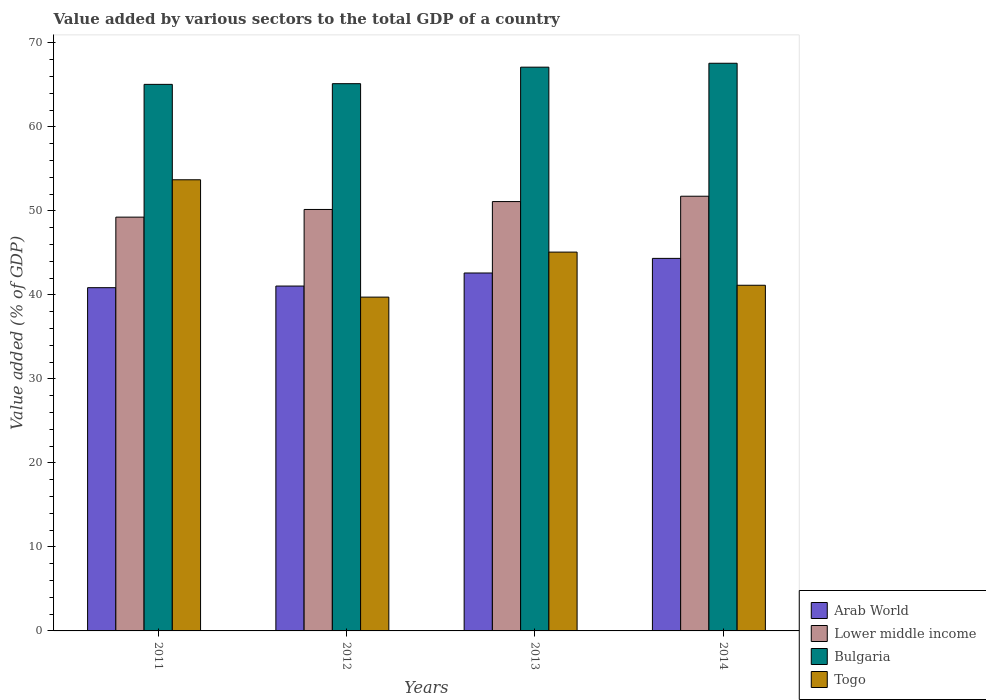How many different coloured bars are there?
Keep it short and to the point. 4. Are the number of bars on each tick of the X-axis equal?
Offer a very short reply. Yes. What is the value added by various sectors to the total GDP in Arab World in 2012?
Your answer should be compact. 41.05. Across all years, what is the maximum value added by various sectors to the total GDP in Togo?
Provide a succinct answer. 53.7. Across all years, what is the minimum value added by various sectors to the total GDP in Bulgaria?
Your response must be concise. 65.06. In which year was the value added by various sectors to the total GDP in Arab World minimum?
Your answer should be compact. 2011. What is the total value added by various sectors to the total GDP in Bulgaria in the graph?
Offer a very short reply. 264.86. What is the difference between the value added by various sectors to the total GDP in Togo in 2011 and that in 2014?
Offer a terse response. 12.56. What is the difference between the value added by various sectors to the total GDP in Arab World in 2011 and the value added by various sectors to the total GDP in Lower middle income in 2013?
Your answer should be compact. -10.25. What is the average value added by various sectors to the total GDP in Arab World per year?
Your answer should be very brief. 42.21. In the year 2011, what is the difference between the value added by various sectors to the total GDP in Lower middle income and value added by various sectors to the total GDP in Bulgaria?
Your answer should be compact. -15.8. What is the ratio of the value added by various sectors to the total GDP in Lower middle income in 2011 to that in 2013?
Offer a terse response. 0.96. Is the value added by various sectors to the total GDP in Bulgaria in 2011 less than that in 2013?
Keep it short and to the point. Yes. What is the difference between the highest and the second highest value added by various sectors to the total GDP in Bulgaria?
Offer a terse response. 0.46. What is the difference between the highest and the lowest value added by various sectors to the total GDP in Bulgaria?
Make the answer very short. 2.51. Is the sum of the value added by various sectors to the total GDP in Lower middle income in 2013 and 2014 greater than the maximum value added by various sectors to the total GDP in Arab World across all years?
Provide a short and direct response. Yes. What does the 4th bar from the left in 2011 represents?
Your answer should be very brief. Togo. What does the 1st bar from the right in 2014 represents?
Provide a short and direct response. Togo. Is it the case that in every year, the sum of the value added by various sectors to the total GDP in Arab World and value added by various sectors to the total GDP in Lower middle income is greater than the value added by various sectors to the total GDP in Bulgaria?
Give a very brief answer. Yes. How many bars are there?
Your answer should be very brief. 16. Are all the bars in the graph horizontal?
Your answer should be compact. No. Does the graph contain grids?
Ensure brevity in your answer.  No. Where does the legend appear in the graph?
Your response must be concise. Bottom right. How are the legend labels stacked?
Offer a terse response. Vertical. What is the title of the graph?
Give a very brief answer. Value added by various sectors to the total GDP of a country. What is the label or title of the X-axis?
Your answer should be compact. Years. What is the label or title of the Y-axis?
Your response must be concise. Value added (% of GDP). What is the Value added (% of GDP) in Arab World in 2011?
Make the answer very short. 40.86. What is the Value added (% of GDP) of Lower middle income in 2011?
Your answer should be compact. 49.25. What is the Value added (% of GDP) of Bulgaria in 2011?
Your answer should be compact. 65.06. What is the Value added (% of GDP) in Togo in 2011?
Provide a short and direct response. 53.7. What is the Value added (% of GDP) of Arab World in 2012?
Give a very brief answer. 41.05. What is the Value added (% of GDP) in Lower middle income in 2012?
Offer a very short reply. 50.16. What is the Value added (% of GDP) in Bulgaria in 2012?
Keep it short and to the point. 65.14. What is the Value added (% of GDP) of Togo in 2012?
Offer a terse response. 39.73. What is the Value added (% of GDP) of Arab World in 2013?
Give a very brief answer. 42.6. What is the Value added (% of GDP) in Lower middle income in 2013?
Make the answer very short. 51.1. What is the Value added (% of GDP) of Bulgaria in 2013?
Your response must be concise. 67.1. What is the Value added (% of GDP) in Togo in 2013?
Keep it short and to the point. 45.09. What is the Value added (% of GDP) of Arab World in 2014?
Your response must be concise. 44.34. What is the Value added (% of GDP) of Lower middle income in 2014?
Your answer should be very brief. 51.74. What is the Value added (% of GDP) in Bulgaria in 2014?
Offer a terse response. 67.57. What is the Value added (% of GDP) of Togo in 2014?
Offer a terse response. 41.14. Across all years, what is the maximum Value added (% of GDP) of Arab World?
Keep it short and to the point. 44.34. Across all years, what is the maximum Value added (% of GDP) in Lower middle income?
Offer a very short reply. 51.74. Across all years, what is the maximum Value added (% of GDP) of Bulgaria?
Give a very brief answer. 67.57. Across all years, what is the maximum Value added (% of GDP) of Togo?
Make the answer very short. 53.7. Across all years, what is the minimum Value added (% of GDP) in Arab World?
Make the answer very short. 40.86. Across all years, what is the minimum Value added (% of GDP) in Lower middle income?
Provide a succinct answer. 49.25. Across all years, what is the minimum Value added (% of GDP) of Bulgaria?
Make the answer very short. 65.06. Across all years, what is the minimum Value added (% of GDP) of Togo?
Make the answer very short. 39.73. What is the total Value added (% of GDP) of Arab World in the graph?
Offer a very short reply. 168.85. What is the total Value added (% of GDP) in Lower middle income in the graph?
Keep it short and to the point. 202.26. What is the total Value added (% of GDP) in Bulgaria in the graph?
Offer a terse response. 264.86. What is the total Value added (% of GDP) of Togo in the graph?
Provide a succinct answer. 179.66. What is the difference between the Value added (% of GDP) in Arab World in 2011 and that in 2012?
Your answer should be very brief. -0.19. What is the difference between the Value added (% of GDP) of Lower middle income in 2011 and that in 2012?
Keep it short and to the point. -0.91. What is the difference between the Value added (% of GDP) in Bulgaria in 2011 and that in 2012?
Make the answer very short. -0.08. What is the difference between the Value added (% of GDP) of Togo in 2011 and that in 2012?
Your response must be concise. 13.97. What is the difference between the Value added (% of GDP) in Arab World in 2011 and that in 2013?
Keep it short and to the point. -1.75. What is the difference between the Value added (% of GDP) in Lower middle income in 2011 and that in 2013?
Make the answer very short. -1.85. What is the difference between the Value added (% of GDP) of Bulgaria in 2011 and that in 2013?
Offer a terse response. -2.05. What is the difference between the Value added (% of GDP) of Togo in 2011 and that in 2013?
Your response must be concise. 8.61. What is the difference between the Value added (% of GDP) in Arab World in 2011 and that in 2014?
Make the answer very short. -3.49. What is the difference between the Value added (% of GDP) in Lower middle income in 2011 and that in 2014?
Make the answer very short. -2.49. What is the difference between the Value added (% of GDP) in Bulgaria in 2011 and that in 2014?
Offer a terse response. -2.51. What is the difference between the Value added (% of GDP) in Togo in 2011 and that in 2014?
Make the answer very short. 12.56. What is the difference between the Value added (% of GDP) in Arab World in 2012 and that in 2013?
Your answer should be very brief. -1.55. What is the difference between the Value added (% of GDP) in Lower middle income in 2012 and that in 2013?
Your response must be concise. -0.94. What is the difference between the Value added (% of GDP) in Bulgaria in 2012 and that in 2013?
Provide a short and direct response. -1.97. What is the difference between the Value added (% of GDP) in Togo in 2012 and that in 2013?
Keep it short and to the point. -5.36. What is the difference between the Value added (% of GDP) in Arab World in 2012 and that in 2014?
Provide a succinct answer. -3.29. What is the difference between the Value added (% of GDP) of Lower middle income in 2012 and that in 2014?
Give a very brief answer. -1.58. What is the difference between the Value added (% of GDP) of Bulgaria in 2012 and that in 2014?
Your answer should be very brief. -2.43. What is the difference between the Value added (% of GDP) in Togo in 2012 and that in 2014?
Offer a very short reply. -1.41. What is the difference between the Value added (% of GDP) of Arab World in 2013 and that in 2014?
Offer a terse response. -1.74. What is the difference between the Value added (% of GDP) in Lower middle income in 2013 and that in 2014?
Offer a terse response. -0.64. What is the difference between the Value added (% of GDP) of Bulgaria in 2013 and that in 2014?
Offer a very short reply. -0.46. What is the difference between the Value added (% of GDP) of Togo in 2013 and that in 2014?
Your answer should be compact. 3.95. What is the difference between the Value added (% of GDP) in Arab World in 2011 and the Value added (% of GDP) in Lower middle income in 2012?
Your answer should be compact. -9.31. What is the difference between the Value added (% of GDP) of Arab World in 2011 and the Value added (% of GDP) of Bulgaria in 2012?
Give a very brief answer. -24.28. What is the difference between the Value added (% of GDP) of Arab World in 2011 and the Value added (% of GDP) of Togo in 2012?
Offer a very short reply. 1.12. What is the difference between the Value added (% of GDP) in Lower middle income in 2011 and the Value added (% of GDP) in Bulgaria in 2012?
Your answer should be very brief. -15.88. What is the difference between the Value added (% of GDP) of Lower middle income in 2011 and the Value added (% of GDP) of Togo in 2012?
Provide a short and direct response. 9.52. What is the difference between the Value added (% of GDP) of Bulgaria in 2011 and the Value added (% of GDP) of Togo in 2012?
Offer a terse response. 25.32. What is the difference between the Value added (% of GDP) of Arab World in 2011 and the Value added (% of GDP) of Lower middle income in 2013?
Your response must be concise. -10.25. What is the difference between the Value added (% of GDP) in Arab World in 2011 and the Value added (% of GDP) in Bulgaria in 2013?
Offer a terse response. -26.25. What is the difference between the Value added (% of GDP) in Arab World in 2011 and the Value added (% of GDP) in Togo in 2013?
Offer a terse response. -4.23. What is the difference between the Value added (% of GDP) of Lower middle income in 2011 and the Value added (% of GDP) of Bulgaria in 2013?
Your answer should be very brief. -17.85. What is the difference between the Value added (% of GDP) in Lower middle income in 2011 and the Value added (% of GDP) in Togo in 2013?
Ensure brevity in your answer.  4.16. What is the difference between the Value added (% of GDP) in Bulgaria in 2011 and the Value added (% of GDP) in Togo in 2013?
Provide a short and direct response. 19.97. What is the difference between the Value added (% of GDP) in Arab World in 2011 and the Value added (% of GDP) in Lower middle income in 2014?
Give a very brief answer. -10.88. What is the difference between the Value added (% of GDP) in Arab World in 2011 and the Value added (% of GDP) in Bulgaria in 2014?
Keep it short and to the point. -26.71. What is the difference between the Value added (% of GDP) in Arab World in 2011 and the Value added (% of GDP) in Togo in 2014?
Ensure brevity in your answer.  -0.29. What is the difference between the Value added (% of GDP) of Lower middle income in 2011 and the Value added (% of GDP) of Bulgaria in 2014?
Provide a short and direct response. -18.32. What is the difference between the Value added (% of GDP) of Lower middle income in 2011 and the Value added (% of GDP) of Togo in 2014?
Give a very brief answer. 8.11. What is the difference between the Value added (% of GDP) of Bulgaria in 2011 and the Value added (% of GDP) of Togo in 2014?
Offer a terse response. 23.91. What is the difference between the Value added (% of GDP) in Arab World in 2012 and the Value added (% of GDP) in Lower middle income in 2013?
Offer a very short reply. -10.05. What is the difference between the Value added (% of GDP) of Arab World in 2012 and the Value added (% of GDP) of Bulgaria in 2013?
Make the answer very short. -26.05. What is the difference between the Value added (% of GDP) in Arab World in 2012 and the Value added (% of GDP) in Togo in 2013?
Your answer should be very brief. -4.04. What is the difference between the Value added (% of GDP) of Lower middle income in 2012 and the Value added (% of GDP) of Bulgaria in 2013?
Give a very brief answer. -16.94. What is the difference between the Value added (% of GDP) of Lower middle income in 2012 and the Value added (% of GDP) of Togo in 2013?
Make the answer very short. 5.08. What is the difference between the Value added (% of GDP) in Bulgaria in 2012 and the Value added (% of GDP) in Togo in 2013?
Make the answer very short. 20.05. What is the difference between the Value added (% of GDP) of Arab World in 2012 and the Value added (% of GDP) of Lower middle income in 2014?
Ensure brevity in your answer.  -10.69. What is the difference between the Value added (% of GDP) of Arab World in 2012 and the Value added (% of GDP) of Bulgaria in 2014?
Your answer should be very brief. -26.52. What is the difference between the Value added (% of GDP) in Arab World in 2012 and the Value added (% of GDP) in Togo in 2014?
Your answer should be very brief. -0.09. What is the difference between the Value added (% of GDP) of Lower middle income in 2012 and the Value added (% of GDP) of Bulgaria in 2014?
Provide a short and direct response. -17.4. What is the difference between the Value added (% of GDP) of Lower middle income in 2012 and the Value added (% of GDP) of Togo in 2014?
Make the answer very short. 9.02. What is the difference between the Value added (% of GDP) in Bulgaria in 2012 and the Value added (% of GDP) in Togo in 2014?
Your answer should be very brief. 23.99. What is the difference between the Value added (% of GDP) of Arab World in 2013 and the Value added (% of GDP) of Lower middle income in 2014?
Your answer should be compact. -9.14. What is the difference between the Value added (% of GDP) of Arab World in 2013 and the Value added (% of GDP) of Bulgaria in 2014?
Keep it short and to the point. -24.96. What is the difference between the Value added (% of GDP) in Arab World in 2013 and the Value added (% of GDP) in Togo in 2014?
Your answer should be compact. 1.46. What is the difference between the Value added (% of GDP) of Lower middle income in 2013 and the Value added (% of GDP) of Bulgaria in 2014?
Keep it short and to the point. -16.46. What is the difference between the Value added (% of GDP) of Lower middle income in 2013 and the Value added (% of GDP) of Togo in 2014?
Offer a very short reply. 9.96. What is the difference between the Value added (% of GDP) of Bulgaria in 2013 and the Value added (% of GDP) of Togo in 2014?
Provide a short and direct response. 25.96. What is the average Value added (% of GDP) of Arab World per year?
Ensure brevity in your answer.  42.21. What is the average Value added (% of GDP) of Lower middle income per year?
Keep it short and to the point. 50.56. What is the average Value added (% of GDP) in Bulgaria per year?
Your answer should be very brief. 66.22. What is the average Value added (% of GDP) in Togo per year?
Give a very brief answer. 44.92. In the year 2011, what is the difference between the Value added (% of GDP) of Arab World and Value added (% of GDP) of Lower middle income?
Provide a short and direct response. -8.4. In the year 2011, what is the difference between the Value added (% of GDP) of Arab World and Value added (% of GDP) of Bulgaria?
Ensure brevity in your answer.  -24.2. In the year 2011, what is the difference between the Value added (% of GDP) in Arab World and Value added (% of GDP) in Togo?
Your response must be concise. -12.84. In the year 2011, what is the difference between the Value added (% of GDP) of Lower middle income and Value added (% of GDP) of Bulgaria?
Offer a terse response. -15.8. In the year 2011, what is the difference between the Value added (% of GDP) of Lower middle income and Value added (% of GDP) of Togo?
Make the answer very short. -4.45. In the year 2011, what is the difference between the Value added (% of GDP) in Bulgaria and Value added (% of GDP) in Togo?
Your answer should be very brief. 11.36. In the year 2012, what is the difference between the Value added (% of GDP) of Arab World and Value added (% of GDP) of Lower middle income?
Keep it short and to the point. -9.12. In the year 2012, what is the difference between the Value added (% of GDP) in Arab World and Value added (% of GDP) in Bulgaria?
Make the answer very short. -24.09. In the year 2012, what is the difference between the Value added (% of GDP) in Arab World and Value added (% of GDP) in Togo?
Provide a succinct answer. 1.32. In the year 2012, what is the difference between the Value added (% of GDP) of Lower middle income and Value added (% of GDP) of Bulgaria?
Offer a terse response. -14.97. In the year 2012, what is the difference between the Value added (% of GDP) in Lower middle income and Value added (% of GDP) in Togo?
Your response must be concise. 10.43. In the year 2012, what is the difference between the Value added (% of GDP) in Bulgaria and Value added (% of GDP) in Togo?
Your response must be concise. 25.4. In the year 2013, what is the difference between the Value added (% of GDP) in Arab World and Value added (% of GDP) in Lower middle income?
Offer a very short reply. -8.5. In the year 2013, what is the difference between the Value added (% of GDP) in Arab World and Value added (% of GDP) in Bulgaria?
Provide a short and direct response. -24.5. In the year 2013, what is the difference between the Value added (% of GDP) of Arab World and Value added (% of GDP) of Togo?
Offer a terse response. -2.49. In the year 2013, what is the difference between the Value added (% of GDP) of Lower middle income and Value added (% of GDP) of Bulgaria?
Offer a terse response. -16. In the year 2013, what is the difference between the Value added (% of GDP) in Lower middle income and Value added (% of GDP) in Togo?
Give a very brief answer. 6.01. In the year 2013, what is the difference between the Value added (% of GDP) of Bulgaria and Value added (% of GDP) of Togo?
Provide a succinct answer. 22.01. In the year 2014, what is the difference between the Value added (% of GDP) of Arab World and Value added (% of GDP) of Lower middle income?
Your answer should be very brief. -7.4. In the year 2014, what is the difference between the Value added (% of GDP) in Arab World and Value added (% of GDP) in Bulgaria?
Your response must be concise. -23.23. In the year 2014, what is the difference between the Value added (% of GDP) in Arab World and Value added (% of GDP) in Togo?
Offer a very short reply. 3.2. In the year 2014, what is the difference between the Value added (% of GDP) of Lower middle income and Value added (% of GDP) of Bulgaria?
Offer a terse response. -15.83. In the year 2014, what is the difference between the Value added (% of GDP) in Lower middle income and Value added (% of GDP) in Togo?
Give a very brief answer. 10.6. In the year 2014, what is the difference between the Value added (% of GDP) of Bulgaria and Value added (% of GDP) of Togo?
Your response must be concise. 26.42. What is the ratio of the Value added (% of GDP) of Lower middle income in 2011 to that in 2012?
Ensure brevity in your answer.  0.98. What is the ratio of the Value added (% of GDP) in Togo in 2011 to that in 2012?
Provide a short and direct response. 1.35. What is the ratio of the Value added (% of GDP) in Arab World in 2011 to that in 2013?
Your response must be concise. 0.96. What is the ratio of the Value added (% of GDP) of Lower middle income in 2011 to that in 2013?
Provide a succinct answer. 0.96. What is the ratio of the Value added (% of GDP) in Bulgaria in 2011 to that in 2013?
Ensure brevity in your answer.  0.97. What is the ratio of the Value added (% of GDP) of Togo in 2011 to that in 2013?
Your answer should be very brief. 1.19. What is the ratio of the Value added (% of GDP) of Arab World in 2011 to that in 2014?
Offer a very short reply. 0.92. What is the ratio of the Value added (% of GDP) in Lower middle income in 2011 to that in 2014?
Ensure brevity in your answer.  0.95. What is the ratio of the Value added (% of GDP) of Bulgaria in 2011 to that in 2014?
Offer a very short reply. 0.96. What is the ratio of the Value added (% of GDP) in Togo in 2011 to that in 2014?
Make the answer very short. 1.31. What is the ratio of the Value added (% of GDP) in Arab World in 2012 to that in 2013?
Provide a short and direct response. 0.96. What is the ratio of the Value added (% of GDP) in Lower middle income in 2012 to that in 2013?
Provide a short and direct response. 0.98. What is the ratio of the Value added (% of GDP) in Bulgaria in 2012 to that in 2013?
Your answer should be very brief. 0.97. What is the ratio of the Value added (% of GDP) in Togo in 2012 to that in 2013?
Make the answer very short. 0.88. What is the ratio of the Value added (% of GDP) of Arab World in 2012 to that in 2014?
Your answer should be very brief. 0.93. What is the ratio of the Value added (% of GDP) in Lower middle income in 2012 to that in 2014?
Keep it short and to the point. 0.97. What is the ratio of the Value added (% of GDP) in Bulgaria in 2012 to that in 2014?
Your answer should be compact. 0.96. What is the ratio of the Value added (% of GDP) of Togo in 2012 to that in 2014?
Give a very brief answer. 0.97. What is the ratio of the Value added (% of GDP) in Arab World in 2013 to that in 2014?
Offer a terse response. 0.96. What is the ratio of the Value added (% of GDP) in Togo in 2013 to that in 2014?
Offer a very short reply. 1.1. What is the difference between the highest and the second highest Value added (% of GDP) in Arab World?
Ensure brevity in your answer.  1.74. What is the difference between the highest and the second highest Value added (% of GDP) in Lower middle income?
Your answer should be very brief. 0.64. What is the difference between the highest and the second highest Value added (% of GDP) of Bulgaria?
Your answer should be very brief. 0.46. What is the difference between the highest and the second highest Value added (% of GDP) of Togo?
Offer a very short reply. 8.61. What is the difference between the highest and the lowest Value added (% of GDP) in Arab World?
Give a very brief answer. 3.49. What is the difference between the highest and the lowest Value added (% of GDP) of Lower middle income?
Offer a very short reply. 2.49. What is the difference between the highest and the lowest Value added (% of GDP) of Bulgaria?
Your answer should be very brief. 2.51. What is the difference between the highest and the lowest Value added (% of GDP) of Togo?
Your answer should be very brief. 13.97. 